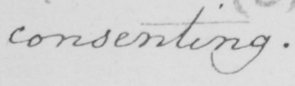Can you tell me what this handwritten text says? consenting  . 